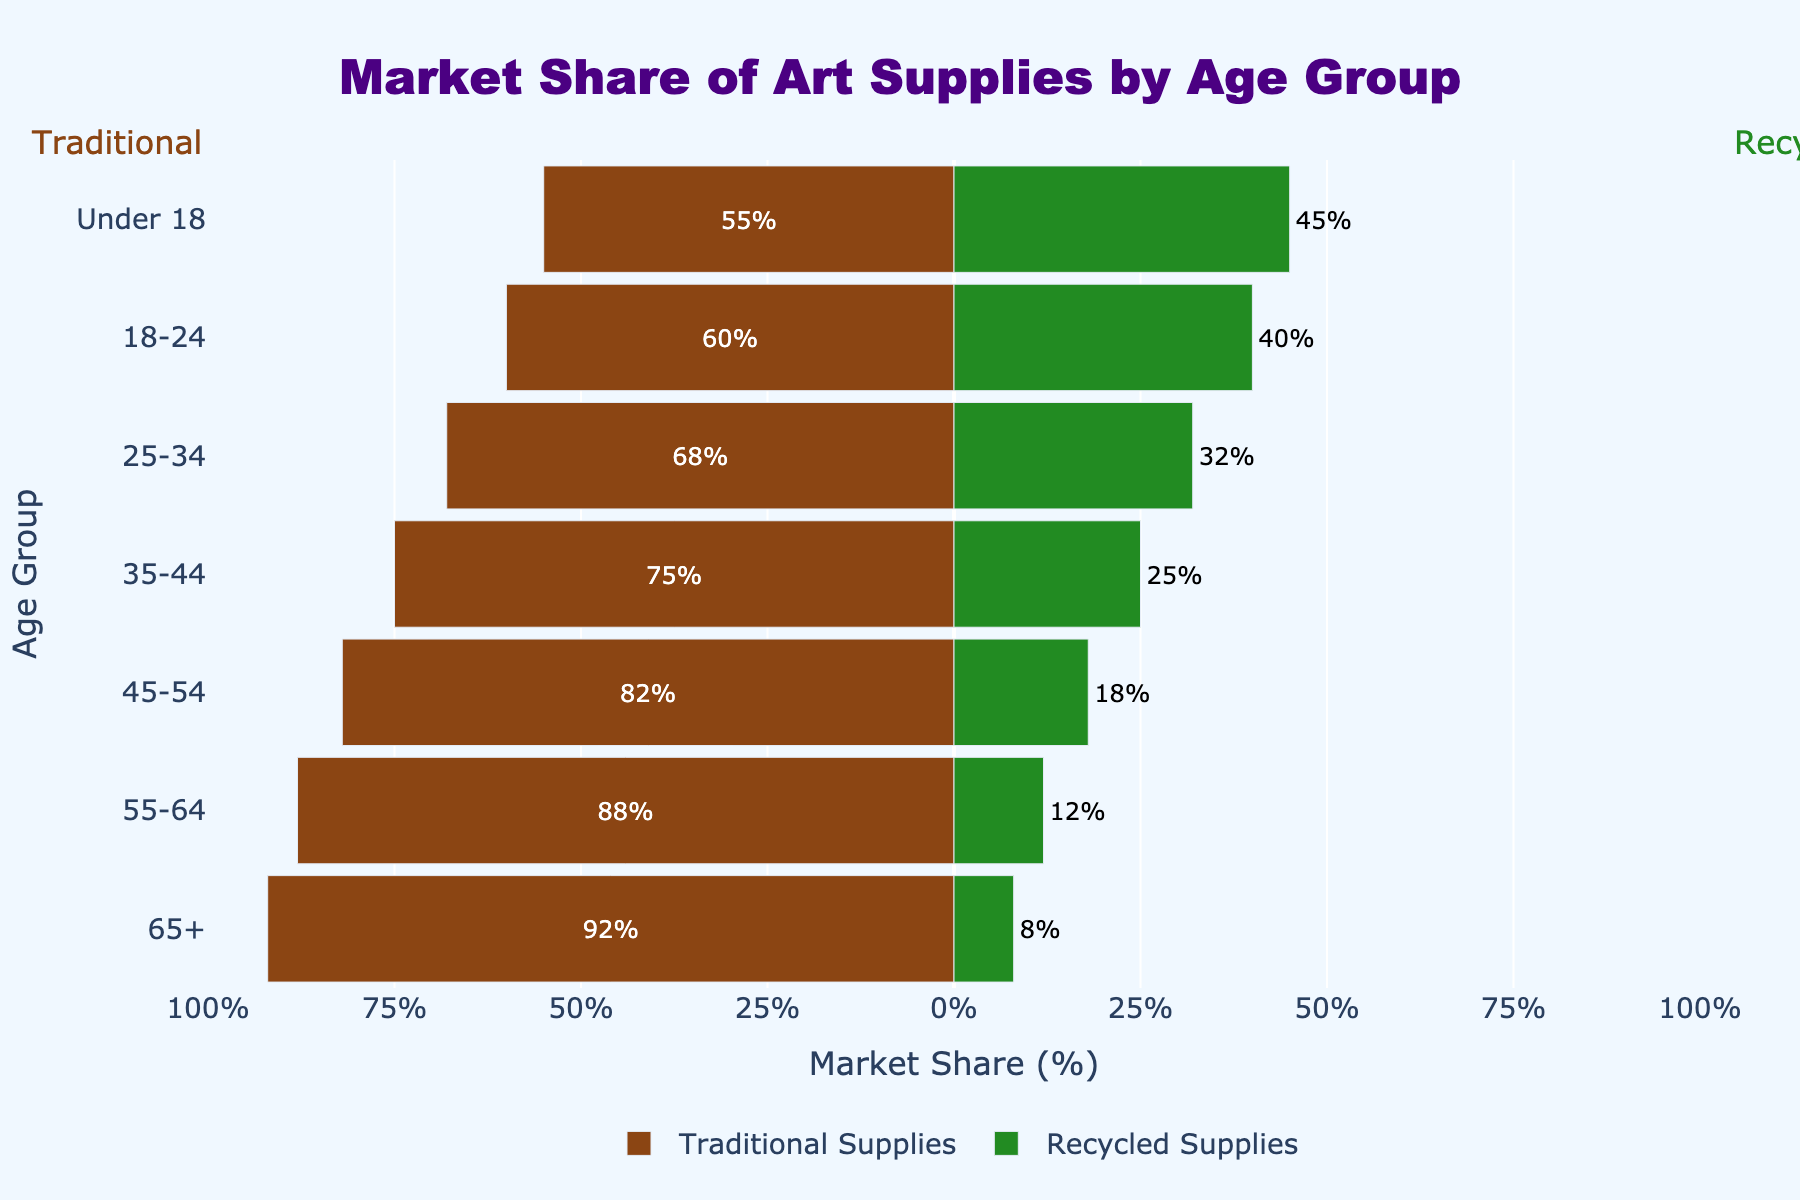what's the title of the plot? The title is displayed at the top of the figure and explains what the data represents.
Answer: Market Share of Art Supplies by Age Group What's the age group with the highest percentage of traditional supplies users? Identify the age group with the longest bar on the left side for traditional supplies. The 65+ age group shows the highest percentage with 92%.
Answer: 65+ What's the age group with an equal proportion of traditional and recycled supplies users? An equal proportion would mean traditional and recycled supplies percentages are the same. None of the age groups have such an equal distribution in this plot.
Answer: None What's the total market share of recycled supplies for the age groups 25-34 and 18-24 combined? Add the percentages of recycled supplies for age groups 25-34 and 18-24 (32% + 40%).
Answer: 72% For which age groups is the market share of traditional supplies less than 70%? Find the age groups with traditional supplies market share below 70%: 25-34, 18-24, Under 18.
Answer: 25-34, 18-24, Under 18 What is the difference in market share of traditional supplies between the age groups 55-64 and 45-54? Subtract the percentage of traditional supplies for the age group 45-54 from the percentage for 55-64 (88% - 82%).
Answer: 6% Which age group has the closest market share between traditional and recycled supplies? Look for the age group with bars of almost equal length: Under 18 (traditional 55%, recycled 45%).
Answer: Under 18 Which type of supply is preferred by the 35-44 age group? The longer bar indicates the preferred type. For the 35-44 age group, traditional supplies (75%) are preferred.
Answer: Traditional supplies How does the market share of traditional supplies trend across the age groups? Analyze the lengths of the traditional supplies bars from younger to older age groups. The market share decreases as age decreases.
Answer: Decreases with younger age groups 